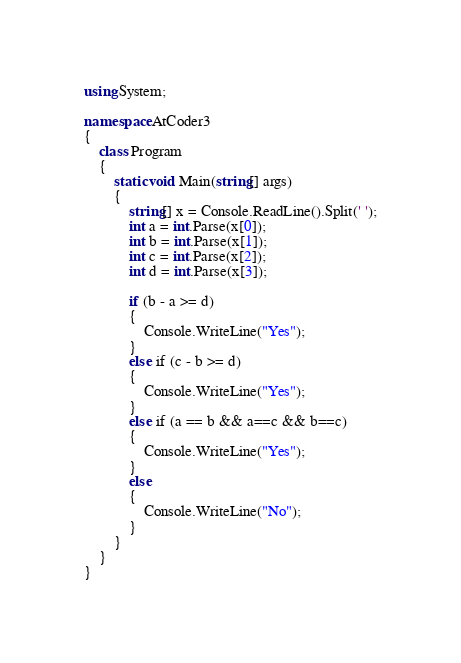<code> <loc_0><loc_0><loc_500><loc_500><_C#_>using System;

namespace AtCoder3
{
    class Program
    {
        static void Main(string[] args)
        {
            string[] x = Console.ReadLine().Split(' ');
            int a = int.Parse(x[0]);
            int b = int.Parse(x[1]);
            int c = int.Parse(x[2]);
            int d = int.Parse(x[3]);

            if (b - a >= d)
            {
                Console.WriteLine("Yes");
            }
            else if (c - b >= d)
            {
                Console.WriteLine("Yes");
            }
            else if (a == b && a==c && b==c)
            {
                Console.WriteLine("Yes");
            }
            else
            {
                Console.WriteLine("No");
            }
        }
    }
}</code> 